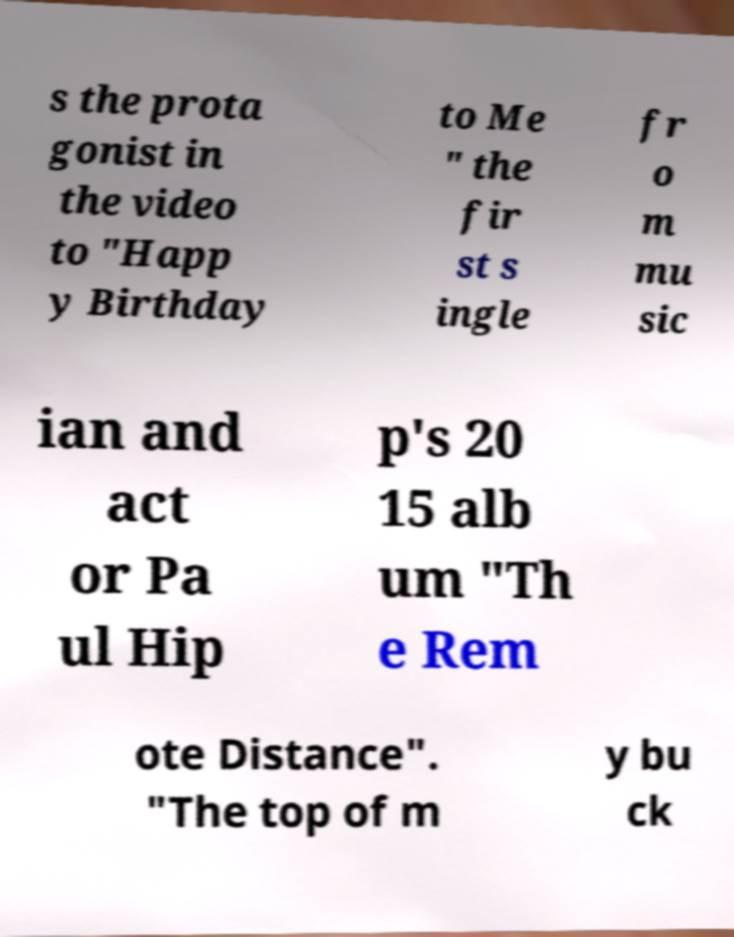What messages or text are displayed in this image? I need them in a readable, typed format. s the prota gonist in the video to "Happ y Birthday to Me " the fir st s ingle fr o m mu sic ian and act or Pa ul Hip p's 20 15 alb um "Th e Rem ote Distance". "The top of m y bu ck 